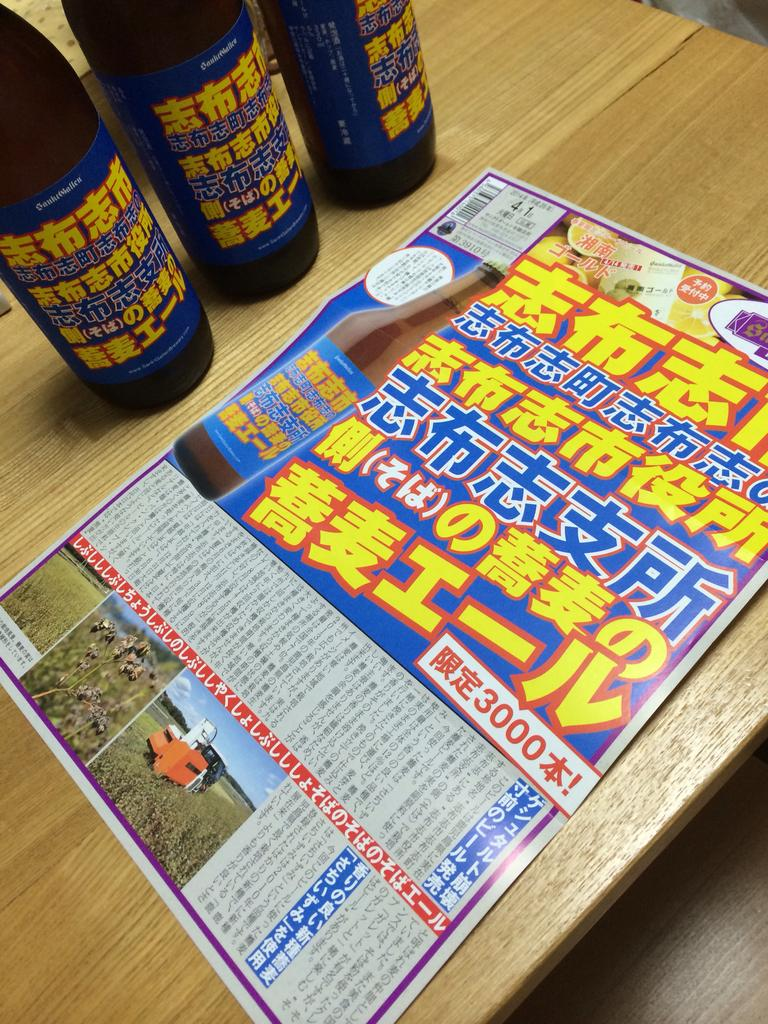<image>
Summarize the visual content of the image. 3 bottles in background and a page showing ad for same bottle with 3000 showing in a box on the page 